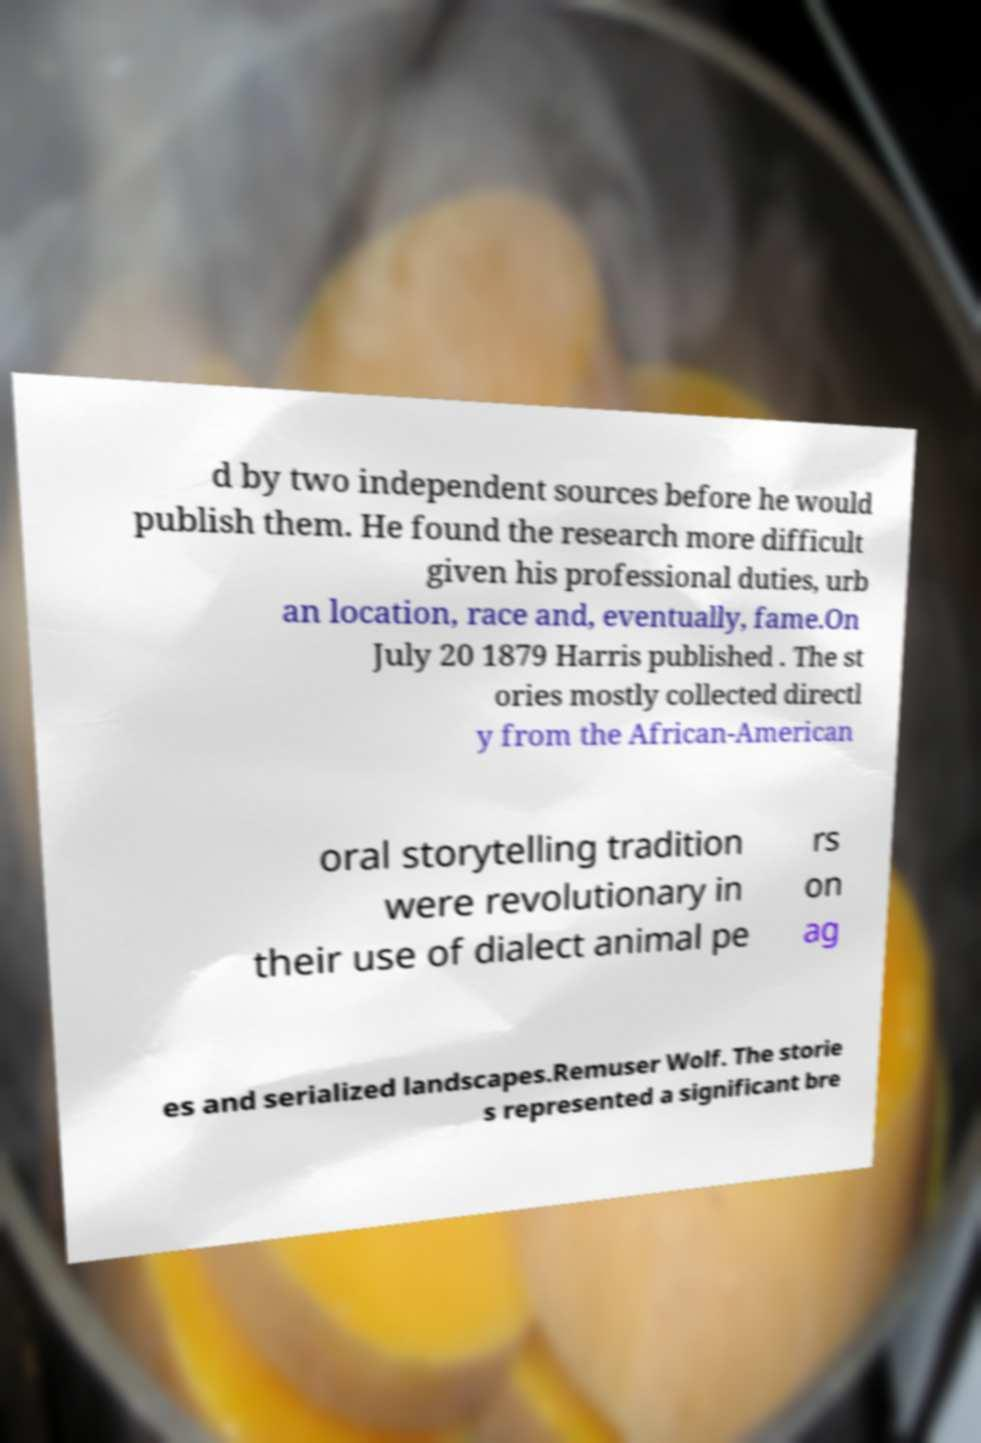Could you extract and type out the text from this image? d by two independent sources before he would publish them. He found the research more difficult given his professional duties, urb an location, race and, eventually, fame.On July 20 1879 Harris published . The st ories mostly collected directl y from the African-American oral storytelling tradition were revolutionary in their use of dialect animal pe rs on ag es and serialized landscapes.Remuser Wolf. The storie s represented a significant bre 